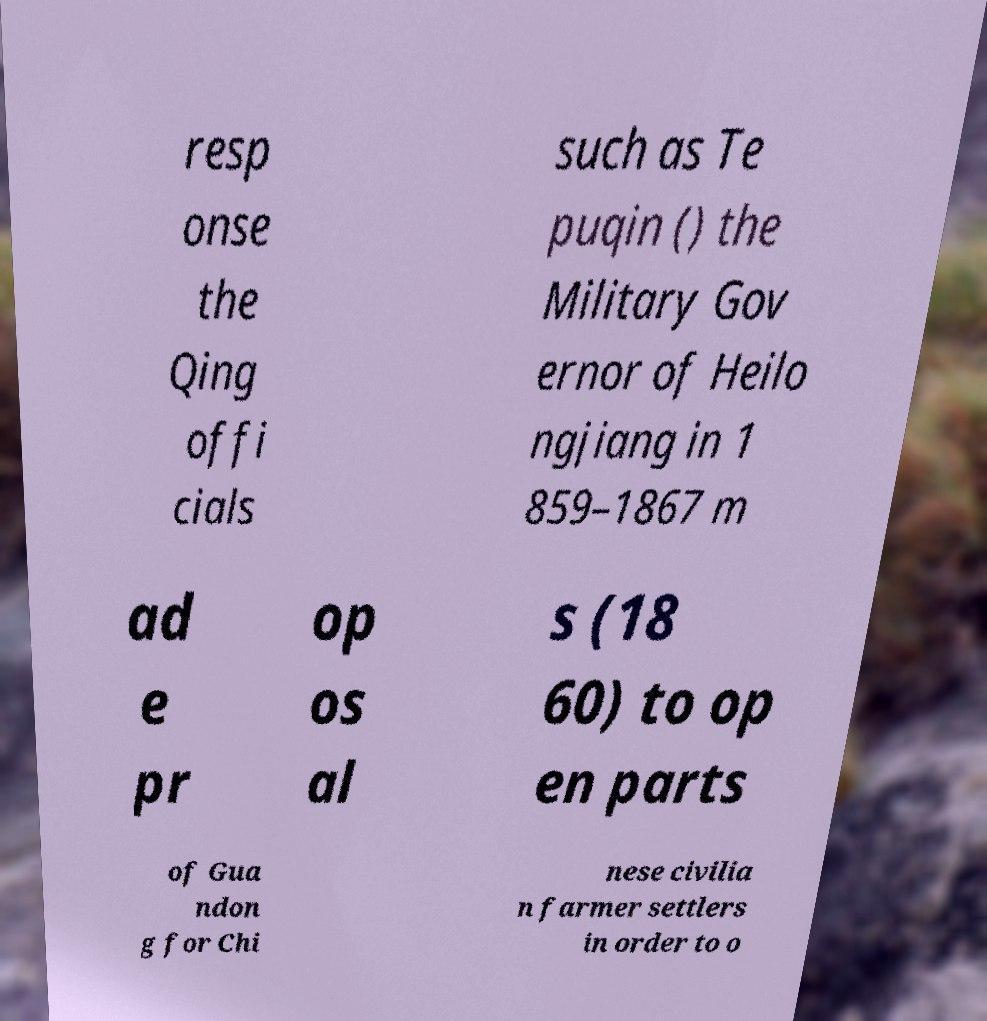Can you read and provide the text displayed in the image?This photo seems to have some interesting text. Can you extract and type it out for me? resp onse the Qing offi cials such as Te puqin () the Military Gov ernor of Heilo ngjiang in 1 859–1867 m ad e pr op os al s (18 60) to op en parts of Gua ndon g for Chi nese civilia n farmer settlers in order to o 